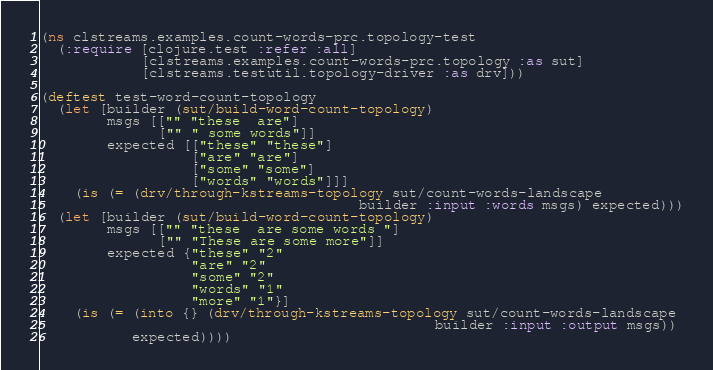<code> <loc_0><loc_0><loc_500><loc_500><_Clojure_>(ns clstreams.examples.count-words-prc.topology-test
  (:require [clojure.test :refer :all]
            [clstreams.examples.count-words-prc.topology :as sut]
            [clstreams.testutil.topology-driver :as drv]))

(deftest test-word-count-topology
  (let [builder (sut/build-word-count-topology)
        msgs [["" "these  are"]
              ["" " some words"]]
        expected [["these" "these"]
                  ["are" "are"]
                  ["some" "some"]
                  ["words" "words"]]]
    (is (= (drv/through-kstreams-topology sut/count-words-landscape
                                      builder :input :words msgs) expected)))
  (let [builder (sut/build-word-count-topology)
        msgs [["" "these  are some words "]
              ["" "These are some more"]]
        expected {"these" "2"
                  "are" "2"
                  "some" "2"
                  "words" "1"
                  "more" "1"}]
    (is (= (into {} (drv/through-kstreams-topology sut/count-words-landscape
                                               builder :input :output msgs))
           expected))))

</code> 